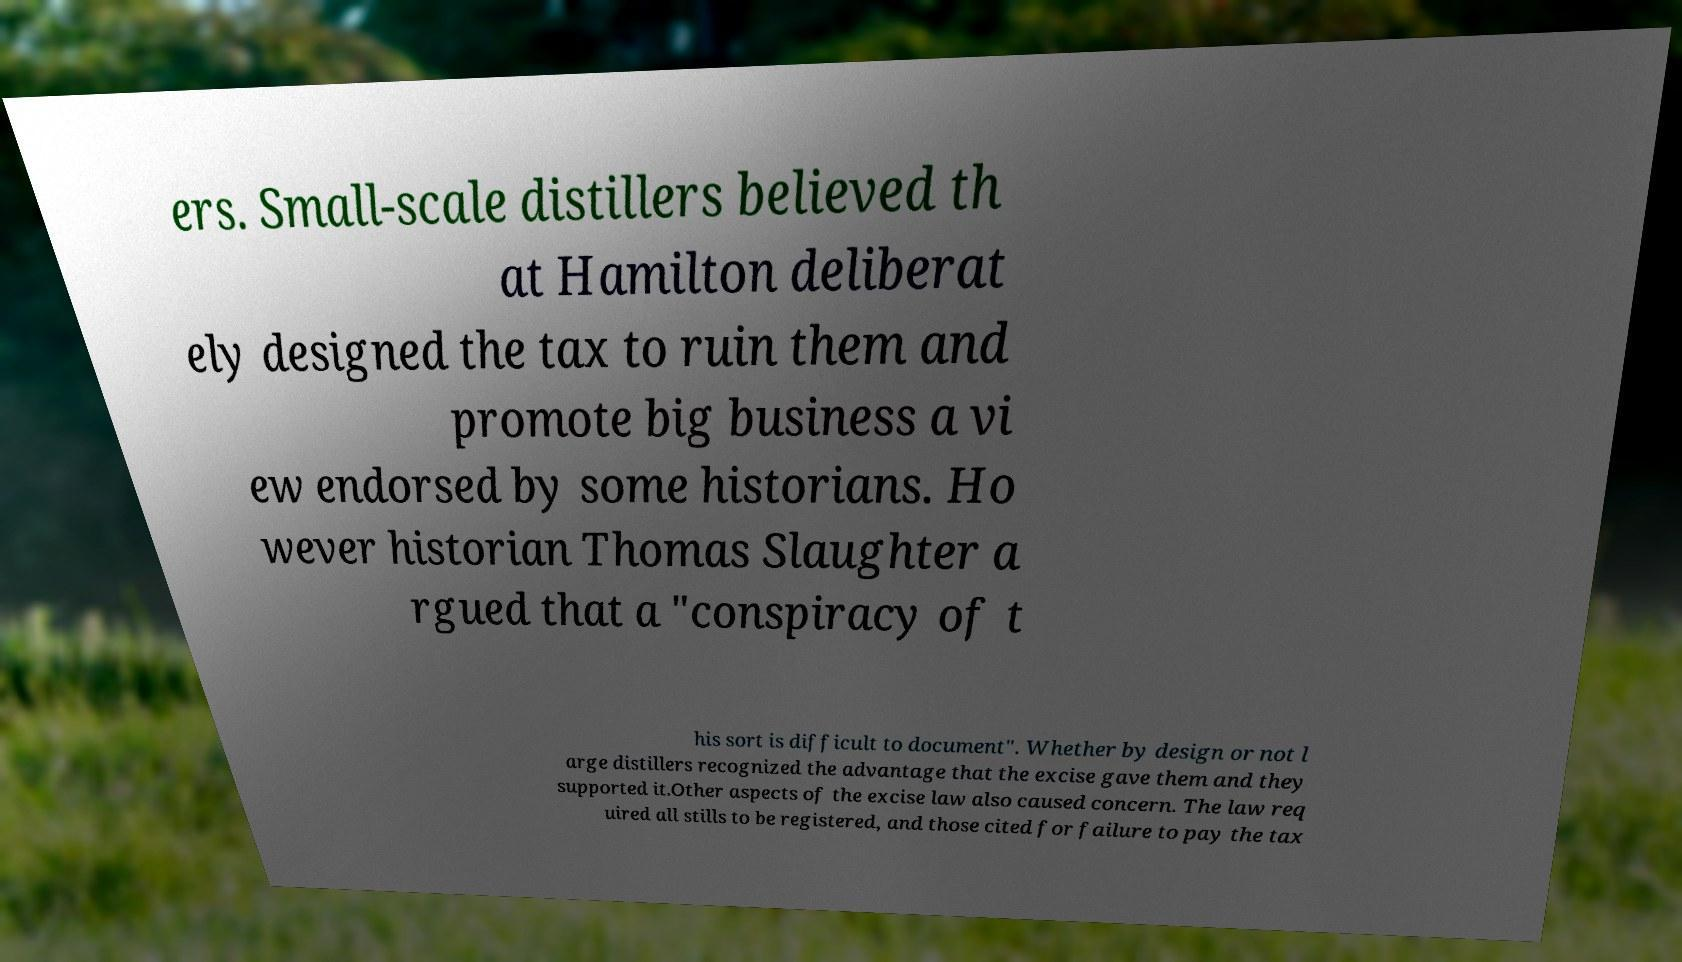Could you extract and type out the text from this image? ers. Small-scale distillers believed th at Hamilton deliberat ely designed the tax to ruin them and promote big business a vi ew endorsed by some historians. Ho wever historian Thomas Slaughter a rgued that a "conspiracy of t his sort is difficult to document". Whether by design or not l arge distillers recognized the advantage that the excise gave them and they supported it.Other aspects of the excise law also caused concern. The law req uired all stills to be registered, and those cited for failure to pay the tax 